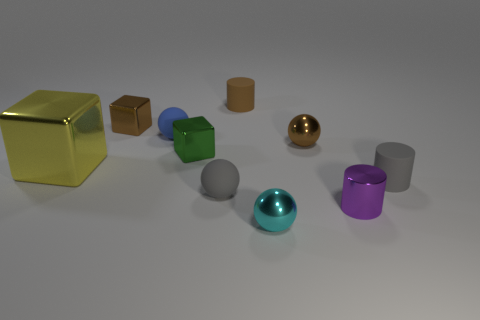Subtract all matte cylinders. How many cylinders are left? 1 Subtract all yellow cubes. How many cubes are left? 2 Subtract all blocks. How many objects are left? 7 Subtract 2 spheres. How many spheres are left? 2 Subtract all gray cylinders. Subtract all cyan blocks. How many cylinders are left? 2 Subtract all red blocks. How many green cylinders are left? 0 Subtract all shiny balls. Subtract all green metal objects. How many objects are left? 7 Add 1 tiny green things. How many tiny green things are left? 2 Add 7 green metallic things. How many green metallic things exist? 8 Subtract 1 brown cylinders. How many objects are left? 9 